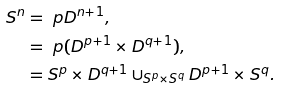<formula> <loc_0><loc_0><loc_500><loc_500>S ^ { n } & = \ p D ^ { n + 1 } , \\ & = \ p ( D ^ { p + 1 } \times D ^ { q + 1 } ) , \\ & = S ^ { p } \times D ^ { q + 1 } \cup _ { S ^ { p } \times S ^ { q } } D ^ { p + 1 } \times S ^ { q } .</formula> 